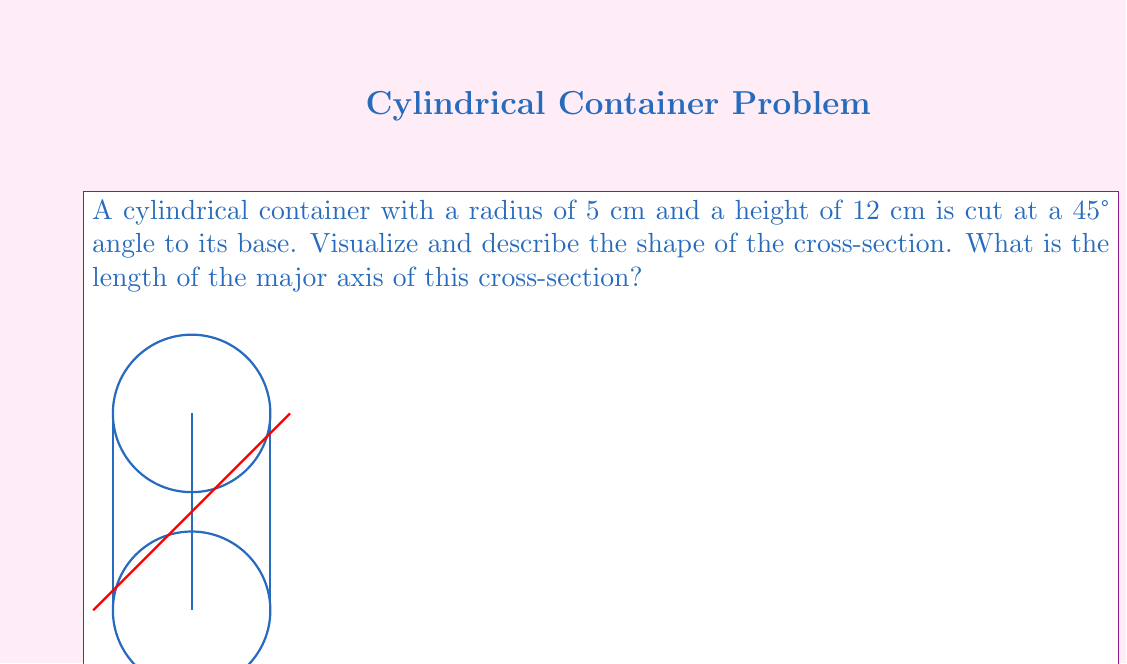Provide a solution to this math problem. Let's approach this step-by-step:

1) When a cylinder is cut at an angle to its base, the resulting cross-section is an ellipse.

2) The minor axis of this ellipse will be equal to the diameter of the cylinder. So, the minor axis is $2r = 2(5) = 10$ cm.

3) To find the major axis, we need to consider the angle of the cut. At a 45° angle, the length of the major axis will be the hypotenuse of a right triangle where:
   - One side is the diameter of the cylinder (10 cm)
   - The other side is the height of the cylinder (12 cm)

4) We can use the Pythagorean theorem to calculate the length of the major axis:

   $$(major axis)^2 = 10^2 + 12^2$$

5) Simplifying:
   $$(major axis)^2 = 100 + 144 = 244$$

6) Taking the square root of both sides:
   $$major axis = \sqrt{244} \approx 15.62 cm$$

Therefore, the length of the major axis of the elliptical cross-section is approximately 15.62 cm.
Answer: $\sqrt{244}$ cm $(\approx 15.62$ cm$)$ 